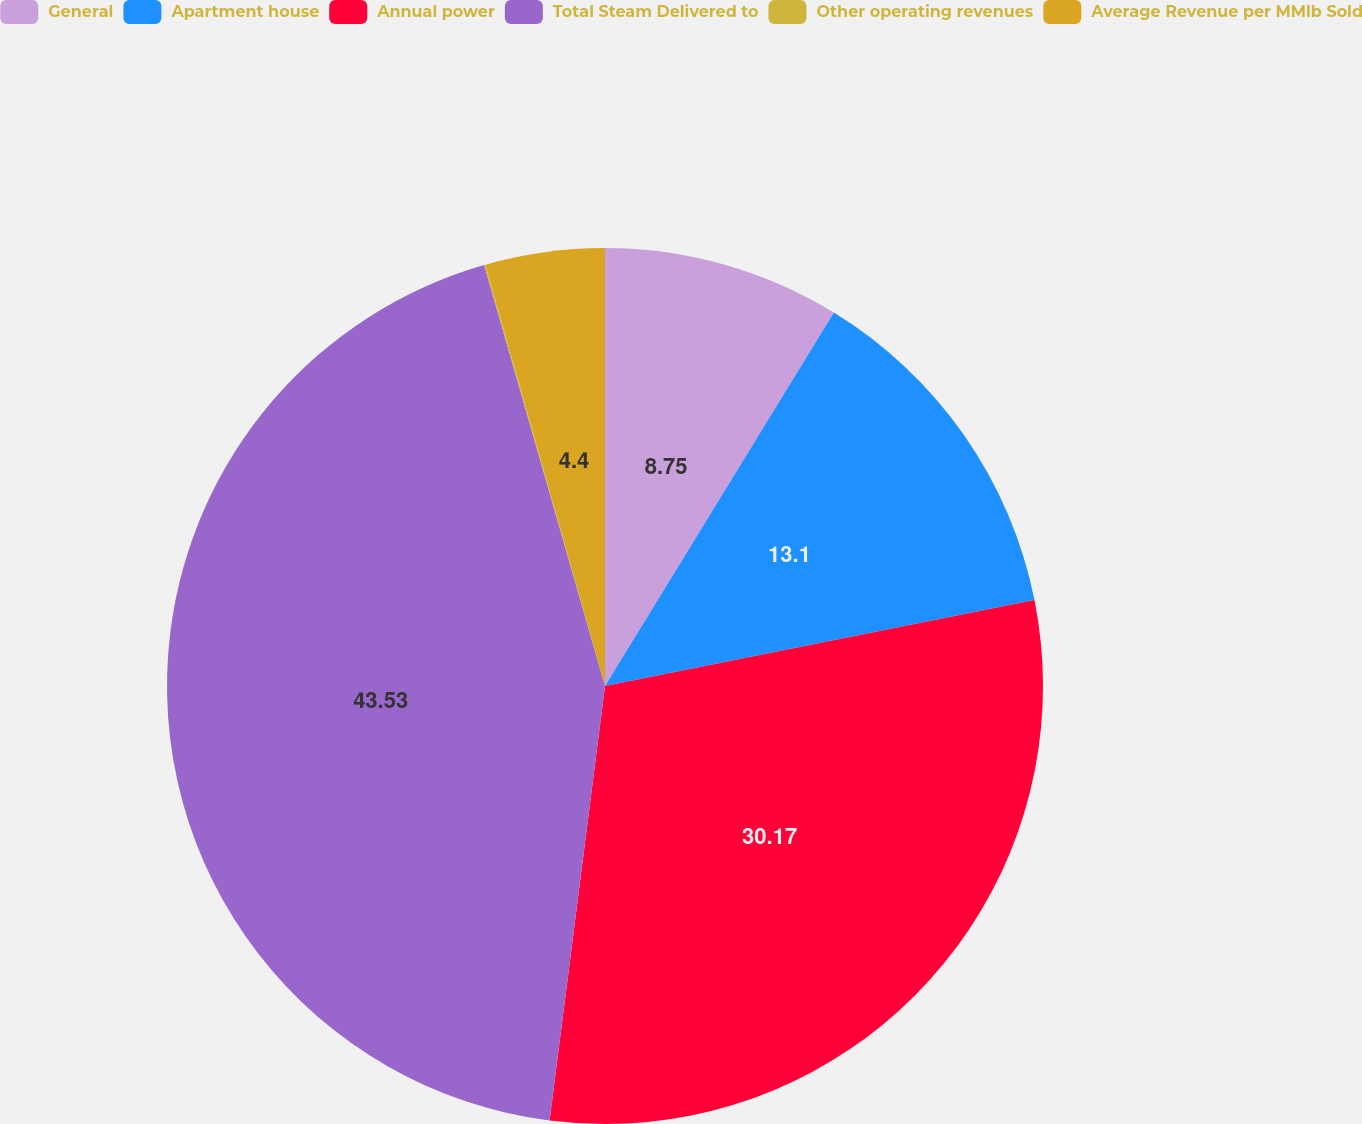<chart> <loc_0><loc_0><loc_500><loc_500><pie_chart><fcel>General<fcel>Apartment house<fcel>Annual power<fcel>Total Steam Delivered to<fcel>Other operating revenues<fcel>Average Revenue per MMlb Sold<nl><fcel>8.75%<fcel>13.1%<fcel>30.17%<fcel>43.53%<fcel>0.05%<fcel>4.4%<nl></chart> 